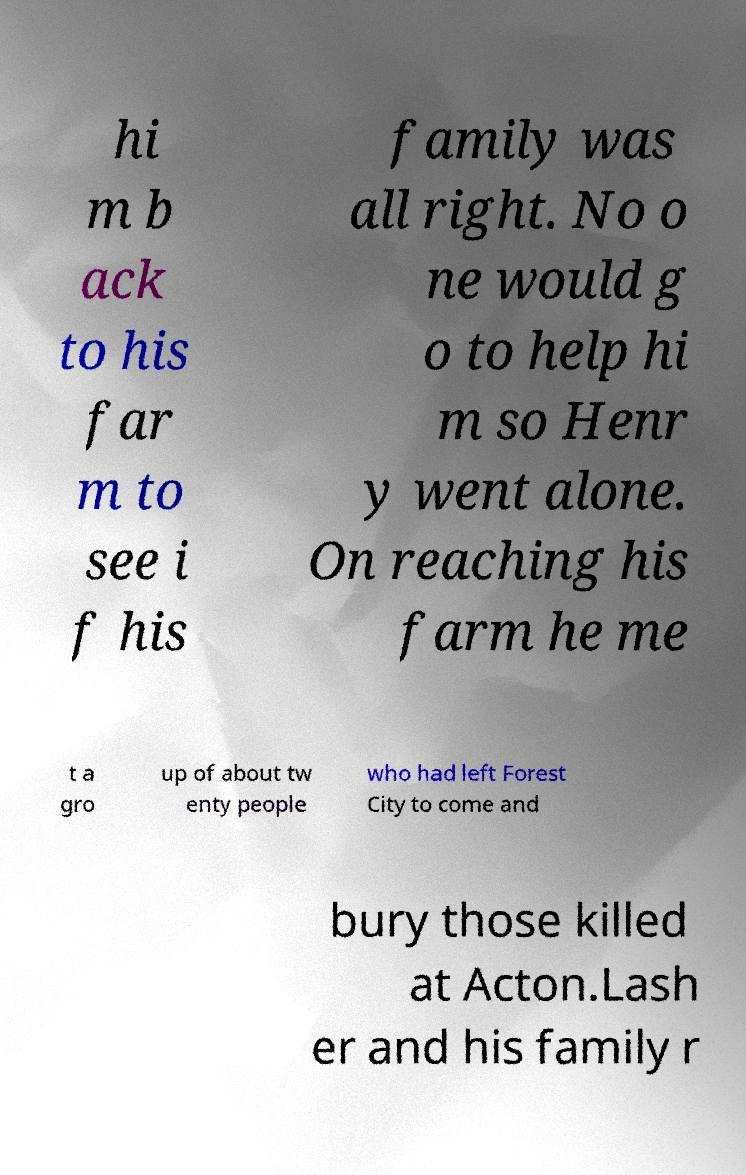I need the written content from this picture converted into text. Can you do that? hi m b ack to his far m to see i f his family was all right. No o ne would g o to help hi m so Henr y went alone. On reaching his farm he me t a gro up of about tw enty people who had left Forest City to come and bury those killed at Acton.Lash er and his family r 